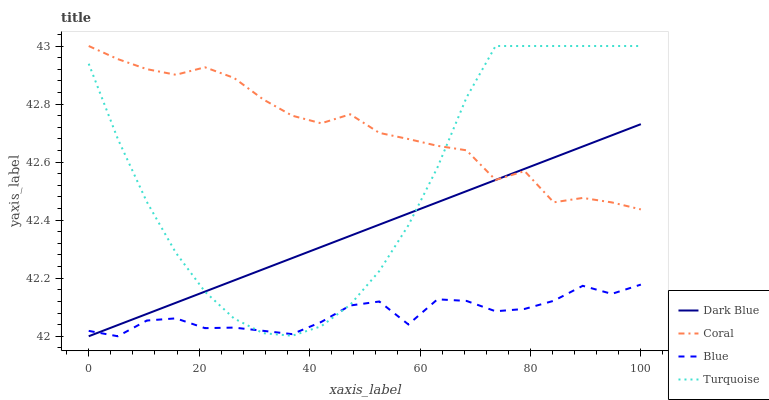Does Blue have the minimum area under the curve?
Answer yes or no. Yes. Does Coral have the maximum area under the curve?
Answer yes or no. Yes. Does Dark Blue have the minimum area under the curve?
Answer yes or no. No. Does Dark Blue have the maximum area under the curve?
Answer yes or no. No. Is Dark Blue the smoothest?
Answer yes or no. Yes. Is Coral the roughest?
Answer yes or no. Yes. Is Coral the smoothest?
Answer yes or no. No. Is Dark Blue the roughest?
Answer yes or no. No. Does Blue have the lowest value?
Answer yes or no. Yes. Does Coral have the lowest value?
Answer yes or no. No. Does Turquoise have the highest value?
Answer yes or no. Yes. Does Dark Blue have the highest value?
Answer yes or no. No. Is Blue less than Coral?
Answer yes or no. Yes. Is Coral greater than Blue?
Answer yes or no. Yes. Does Dark Blue intersect Turquoise?
Answer yes or no. Yes. Is Dark Blue less than Turquoise?
Answer yes or no. No. Is Dark Blue greater than Turquoise?
Answer yes or no. No. Does Blue intersect Coral?
Answer yes or no. No. 